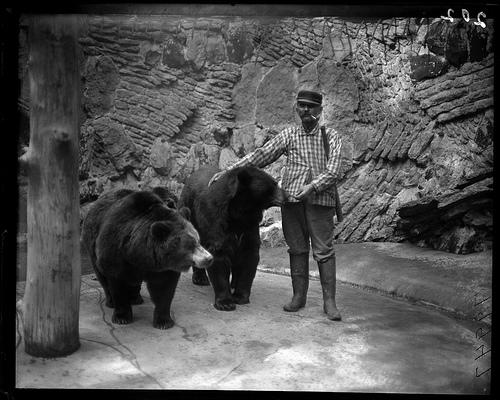Does the man have something in his mouth?
Concise answer only. Yes. Does that man have a bed roll?
Keep it brief. No. Are the bears real?
Give a very brief answer. Yes. Which bear is wearing a striped sweater?
Write a very short answer. None. What is this bear doing?
Answer briefly. Standing. How many people are in this picture?
Keep it brief. 1. What are the two animals in this picture?
Quick response, please. Bears. What animal is shown?
Keep it brief. Bear. Which bear has an open mouth?
Answer briefly. Neither. Which bear has his mouth open?
Keep it brief. Neither. 